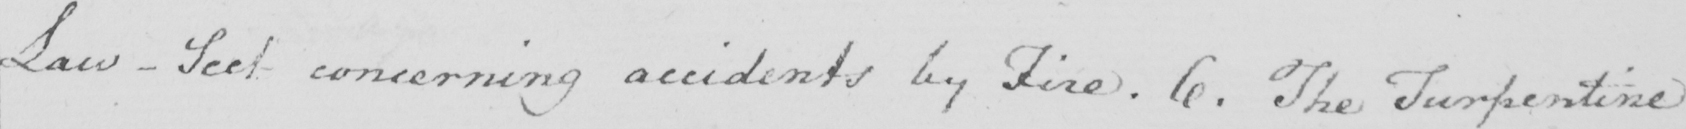Can you tell me what this handwritten text says? Law - Sect concerning accidents by Fire . 6 . The Turpentine 